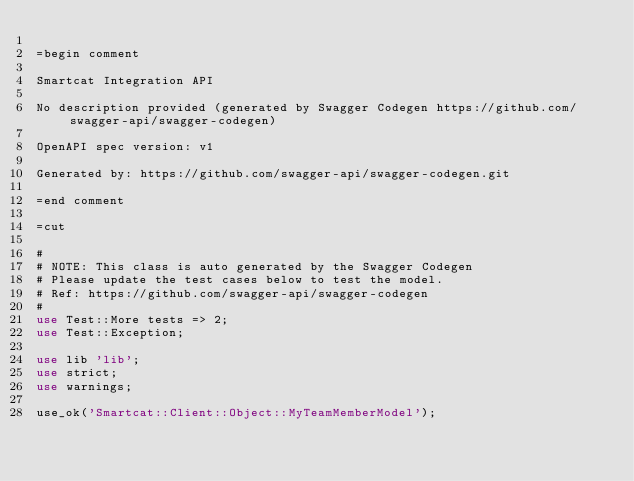<code> <loc_0><loc_0><loc_500><loc_500><_Perl_>
=begin comment

Smartcat Integration API

No description provided (generated by Swagger Codegen https://github.com/swagger-api/swagger-codegen)

OpenAPI spec version: v1

Generated by: https://github.com/swagger-api/swagger-codegen.git

=end comment

=cut

#
# NOTE: This class is auto generated by the Swagger Codegen
# Please update the test cases below to test the model.
# Ref: https://github.com/swagger-api/swagger-codegen
#
use Test::More tests => 2;
use Test::Exception;

use lib 'lib';
use strict;
use warnings;

use_ok('Smartcat::Client::Object::MyTeamMemberModel');
</code> 